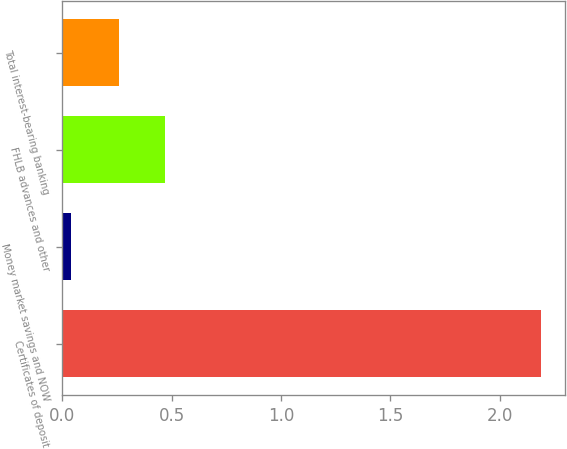<chart> <loc_0><loc_0><loc_500><loc_500><bar_chart><fcel>Certificates of deposit<fcel>Money market savings and NOW<fcel>FHLB advances and other<fcel>Total interest-bearing banking<nl><fcel>2.19<fcel>0.04<fcel>0.47<fcel>0.26<nl></chart> 